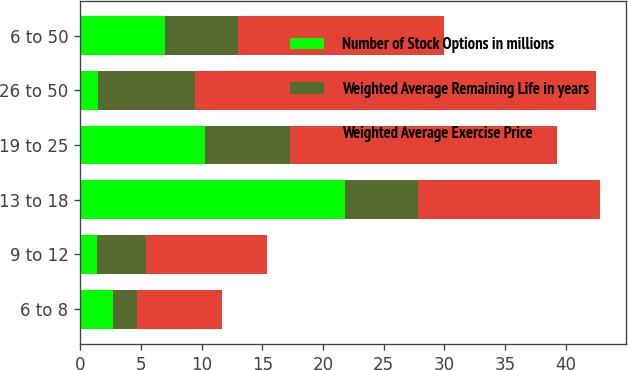Convert chart to OTSL. <chart><loc_0><loc_0><loc_500><loc_500><stacked_bar_chart><ecel><fcel>6 to 8<fcel>9 to 12<fcel>13 to 18<fcel>19 to 25<fcel>26 to 50<fcel>6 to 50<nl><fcel>Number of Stock Options in millions<fcel>2.7<fcel>1.4<fcel>21.8<fcel>10.3<fcel>1.5<fcel>7<nl><fcel>Weighted Average Remaining Life in years<fcel>2<fcel>4<fcel>6<fcel>7<fcel>8<fcel>6<nl><fcel>Weighted Average Exercise Price<fcel>7<fcel>10<fcel>15<fcel>22<fcel>33<fcel>17<nl></chart> 